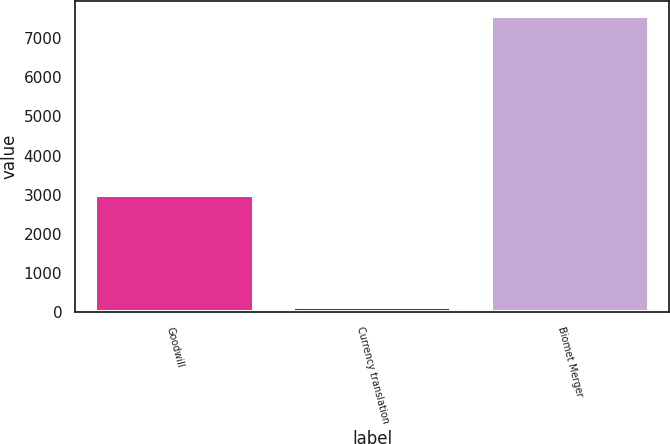Convert chart to OTSL. <chart><loc_0><loc_0><loc_500><loc_500><bar_chart><fcel>Goodwill<fcel>Currency translation<fcel>Biomet Merger<nl><fcel>2984.2<fcel>137.6<fcel>7573.9<nl></chart> 